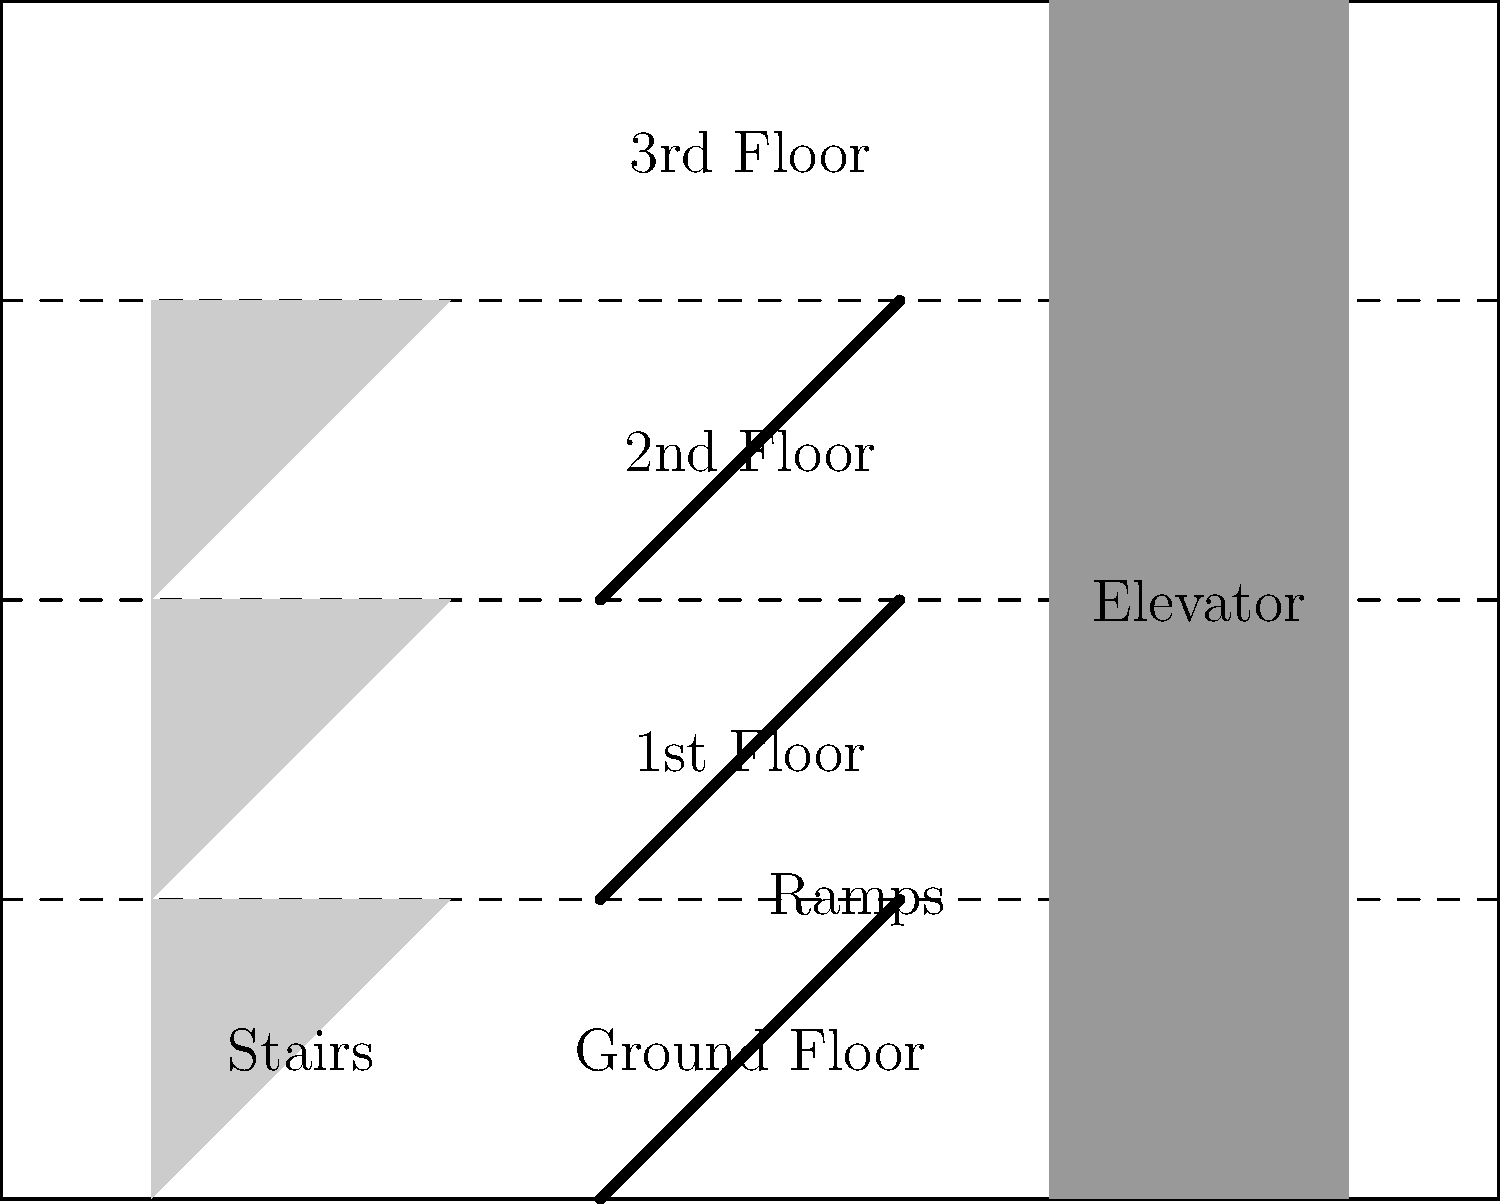In the given multi-story building blueprint, ramps have been installed to improve accessibility between floors. If the building code requires a maximum ramp slope of 1:12 (rise:run), what is the minimum horizontal distance needed for each ramp to connect adjacent floors that are 10 feet apart vertically? To solve this problem, we need to follow these steps:

1. Understand the given information:
   - The ramp slope requirement is 1:12 (rise:run)
   - The vertical distance between floors is 10 feet

2. Set up the ratio equation:
   Let x be the horizontal distance (run) we're looking for.
   $\frac{\text{rise}}{\text{run}} = \frac{1}{12}$

3. Plug in the known values:
   $\frac{10}{x} = \frac{1}{12}$

4. Cross multiply to solve for x:
   $12 \cdot 10 = 1 \cdot x$
   $120 = x$

5. Interpret the result:
   The minimum horizontal distance needed for each ramp is 120 feet.

This solution ensures that the ramp meets the maximum slope requirement of 1:12, making it accessible for individuals with mobility limitations. As a social worker focused on improving accessibility, this calculation is crucial for ensuring that building designs comply with accessibility standards and provide safe, usable ramps for all individuals.
Answer: 120 feet 